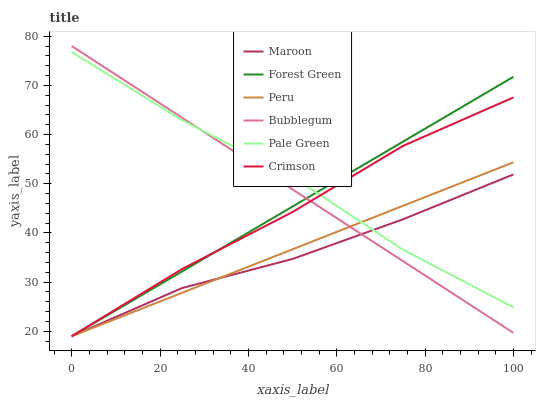Does Maroon have the minimum area under the curve?
Answer yes or no. Yes. Does Pale Green have the maximum area under the curve?
Answer yes or no. Yes. Does Forest Green have the minimum area under the curve?
Answer yes or no. No. Does Forest Green have the maximum area under the curve?
Answer yes or no. No. Is Peru the smoothest?
Answer yes or no. Yes. Is Pale Green the roughest?
Answer yes or no. Yes. Is Forest Green the smoothest?
Answer yes or no. No. Is Forest Green the roughest?
Answer yes or no. No. Does Forest Green have the lowest value?
Answer yes or no. Yes. Does Pale Green have the lowest value?
Answer yes or no. No. Does Bubblegum have the highest value?
Answer yes or no. Yes. Does Forest Green have the highest value?
Answer yes or no. No. Does Pale Green intersect Peru?
Answer yes or no. Yes. Is Pale Green less than Peru?
Answer yes or no. No. Is Pale Green greater than Peru?
Answer yes or no. No. 